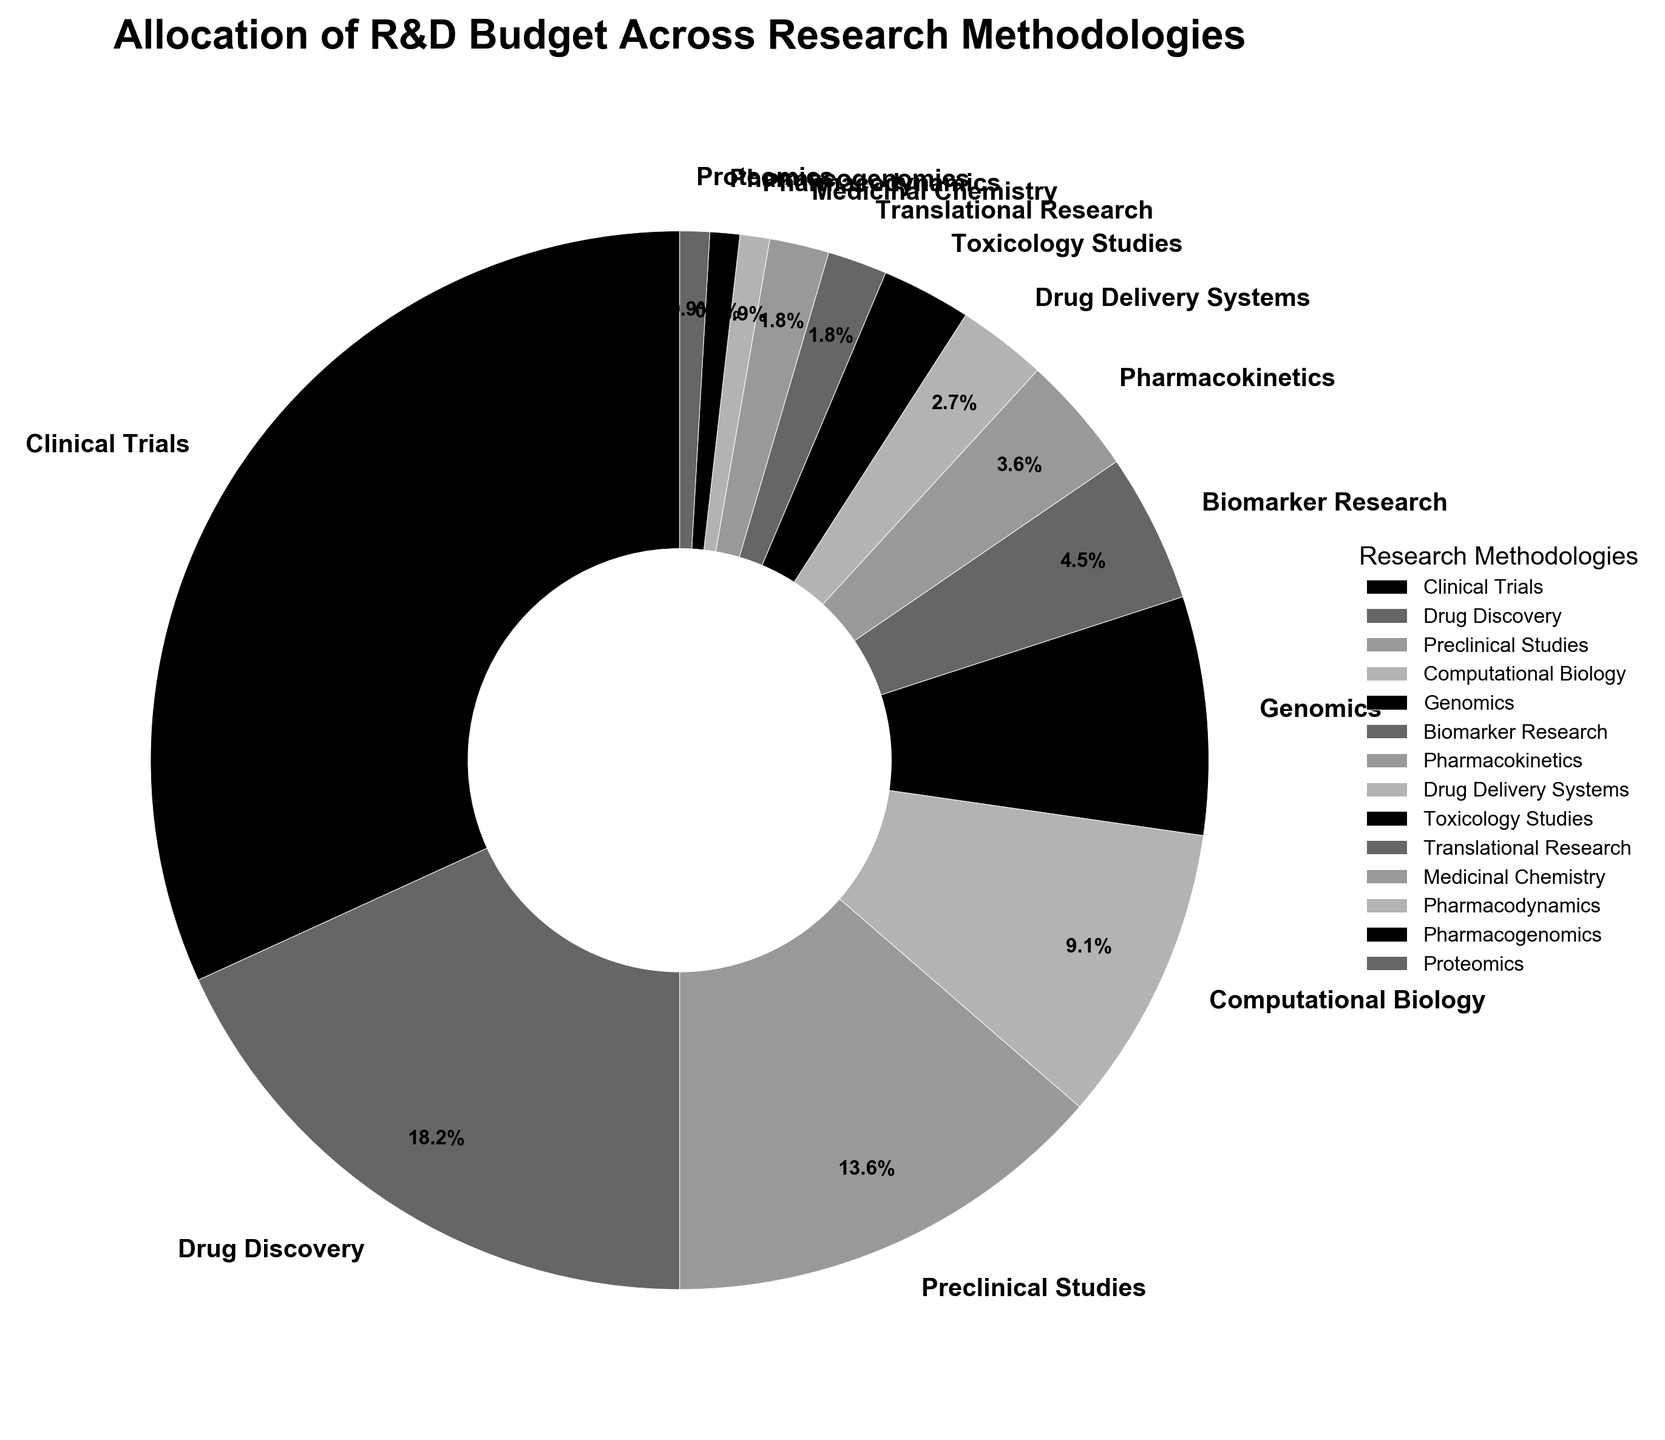What percentage of the R&D budget is allocated to Clinical Trials? From the pie chart, Clinical Trials are allocated 35% of the R&D budget. This percentage is directly displayed on the chart.
Answer: 35% How much more budget is allocated to Clinical Trials compared to Drug Discovery? Clinical Trials are allocated 35% and Drug Discovery is allocated 20%. The difference is 35% - 20% = 15%.
Answer: 15% Which three methodologies have the smallest budget allocation, and what is their total percentage? The three methodologies with the smallest budget allocation are Pharmacodynamics (1%), Pharmacogenomics (1%), and Proteomics (1%). Their total is 1% + 1% + 1% = 3%.
Answer: Pharmacodynamics, Pharmacogenomics, Proteomics; 3% What is the combined budget percentage for Preclinical Studies and Computational Biology? Preclinical Studies are allocated 15% and Computational Biology 10%. Their combined percentage is 15% + 10% = 25%.
Answer: 25% How does the budget allocation for Genomics compare to that for Biomarker Research? Genomics is allocated 8%, and Biomarker Research 5%. Genomics has a 3% higher allocation.
Answer: Genomics has 3% more Is the budget for Drug Delivery Systems and Toxicology Studies the same? Yes, both Drug Delivery Systems and Toxicology Studies are allocated 3% of the budget. The chart shows identical percentages for these two methodologies.
Answer: Yes, they are the same If you sum the budget allocations for the methodologies with single-digit percentages, what is the total? Adding up the single-digit allocations: Computational Biology (10%), Genomics (8%), Biomarker Research (5%), Pharmacokinetics (4%), Drug Delivery Systems (3%), Toxicology Studies (3%), Translational Research (2%), Medicinal Chemistry (2%), Pharmacodynamics (1%), Pharmacogenomics (1%), Proteomics (1%) gives 10% + 8% + 5% + 4% + 3% + 3% + 2% + 2% + 1% + 1% + 1% = 40%.
Answer: 40% Which research methodology has a greater budget allocation: Computational Biology or Preclinical Studies? Preclinical Studies are allocated 15%, while Computational Biology is allocated 10%, thus Preclinical Studies have a greater allocation.
Answer: Preclinical Studies How many research methodologies are allocated more than 10% of the budget? From the chart, only Clinical Trials (35%) and Drug Discovery (20%) have more than 10% allocation. So, there are 2 methodologies.
Answer: 2 Is Preclinical Studies allocated a higher budget percentage than Drug Discovery? Drug Discovery is allocated 20%, while Preclinical Studies is allocated 15%. Therefore, Drug Discovery has a higher budget allocation.
Answer: No 